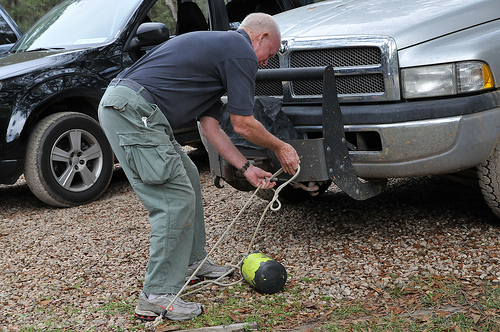Which kind of vehicle is silver? The truck in the image is silver, adding a bit of sheen to the outdoor setting. 